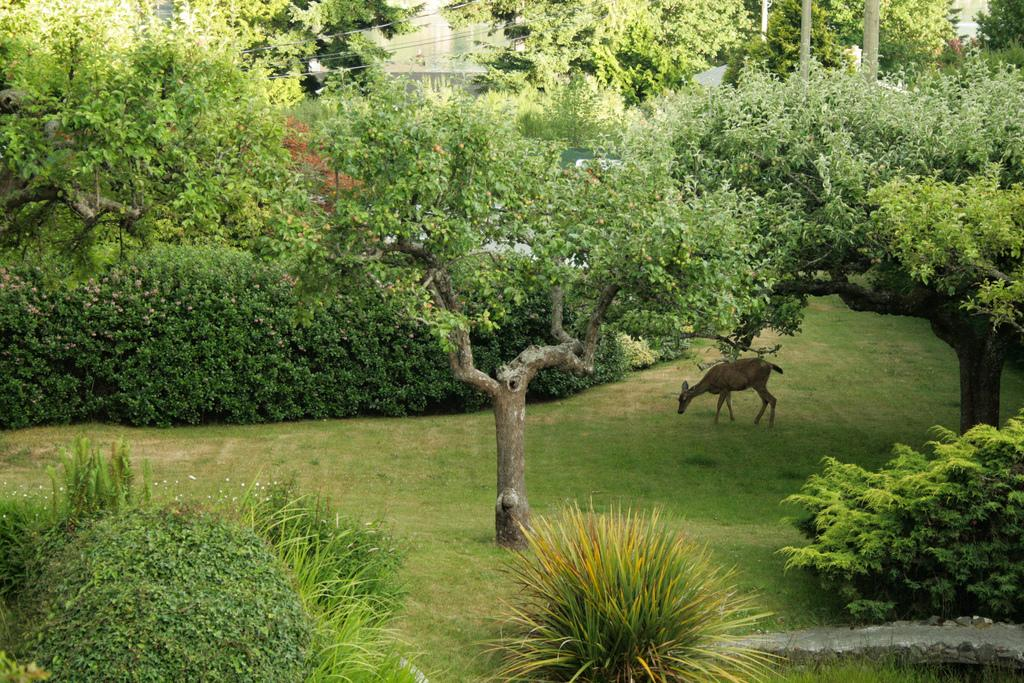What type of vegetation is present in the image? There is grass, plants, and trees visible in the image. What kind of animal can be seen in the image? There is a deer in the image. What can be seen in the background of the image? There are buildings, trees, additional plants, and poles in the background of the image. How many snails can be seen crawling on the plants in the image? There are no snails visible in the image; only the deer, vegetation, and background elements are present. 